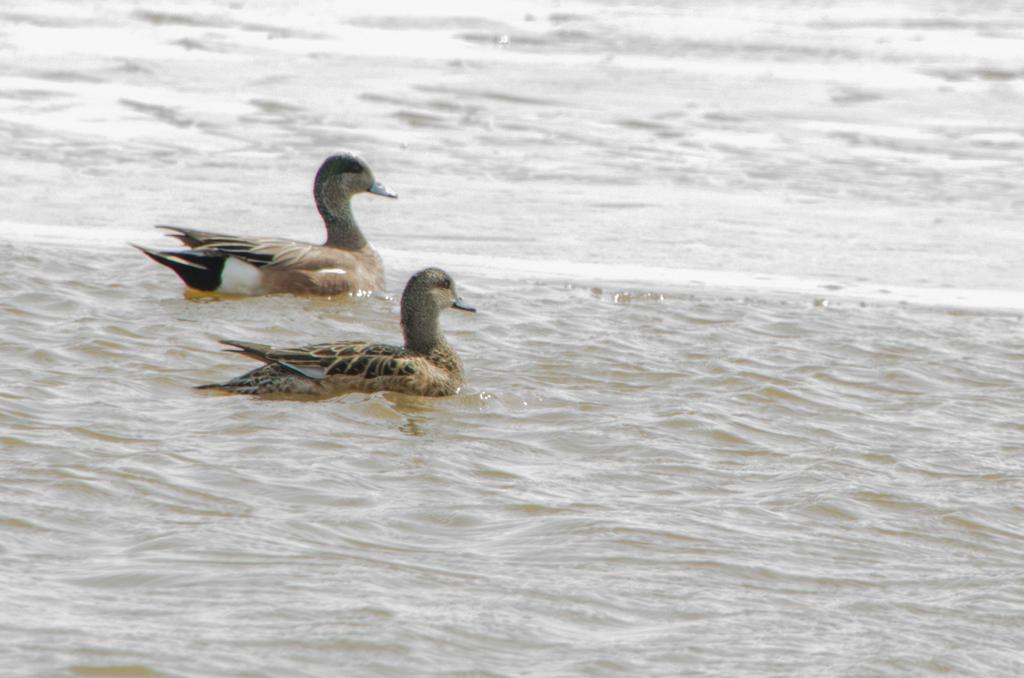What body of water is present in the image? There is a river in the image. What animals can be seen in the river? There are two ducks in the river. On which side of the image are the ducks located? The ducks are on the left side of the image. In which direction are the ducks facing? The ducks are facing towards the right side of the image. What type of machine is being offered by the ducks in the image? There is no machine present in the image, and the ducks are not offering anything. 